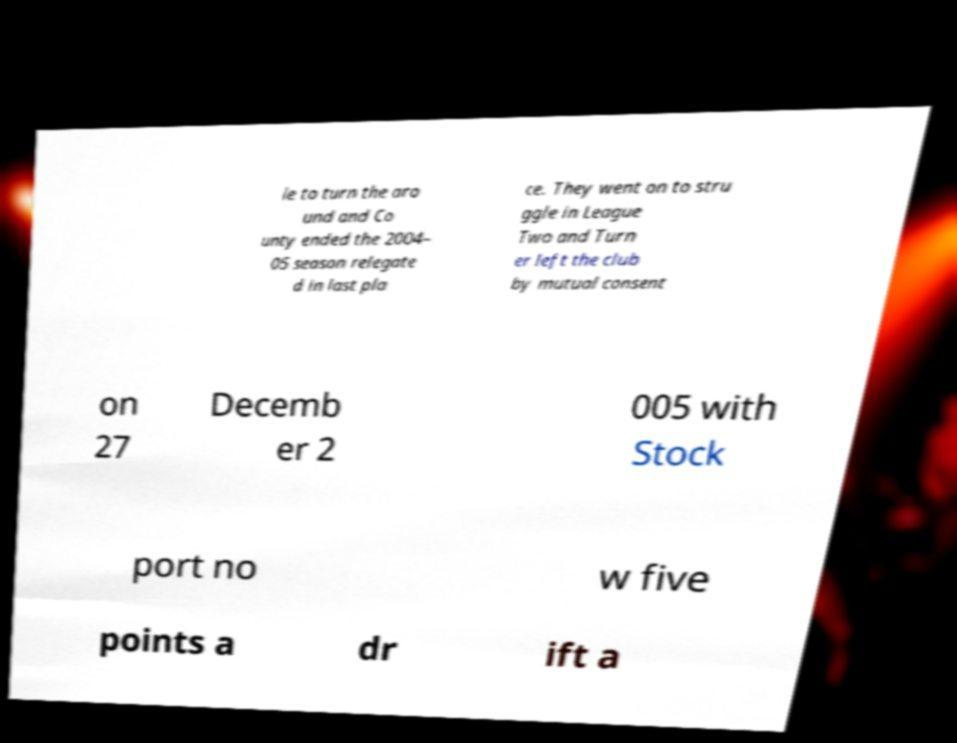Please read and relay the text visible in this image. What does it say? le to turn the aro und and Co unty ended the 2004– 05 season relegate d in last pla ce. They went on to stru ggle in League Two and Turn er left the club by mutual consent on 27 Decemb er 2 005 with Stock port no w five points a dr ift a 